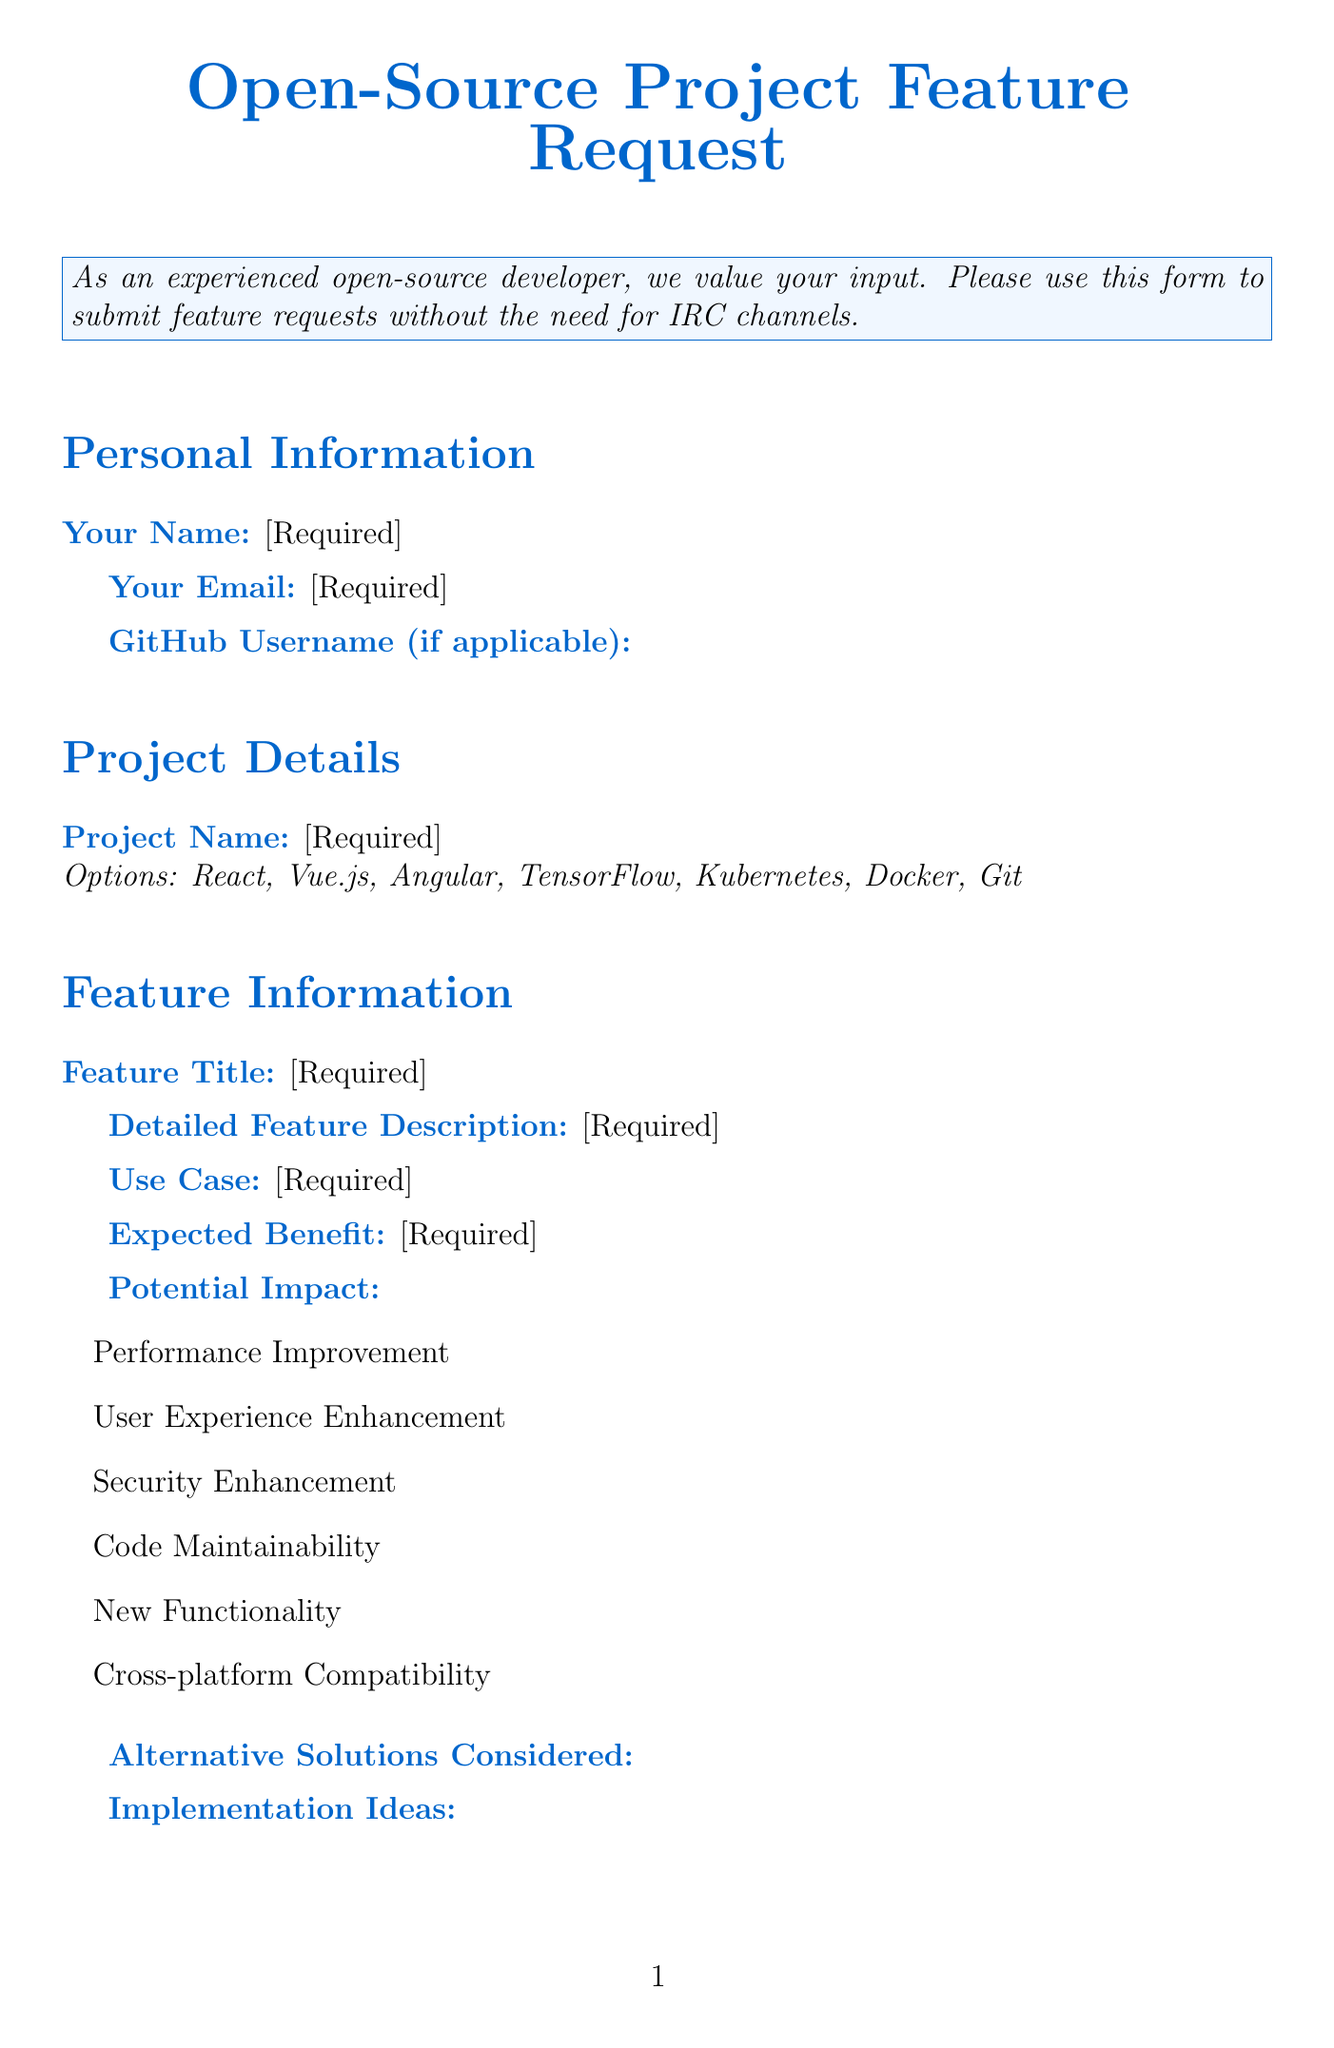what is the title of the form? The title of the form is presented at the top of the document.
Answer: Open-Source Project Feature Request what types of projects can you select? The options for project names are provided in a dropdown list in the document.
Answer: React, Vue.js, Angular, TensorFlow, Kubernetes, Docker, Git which field is required for the requester? The document specifies which fields are marked as required.
Answer: Your Name, Your Email, Project Name, Feature Title, Detailed Feature Description, Use Case, Expected Benefit, Priority, Estimated Complexity, Are you willing to contribute to the implementation?, Preferred Communication Method how many options are available for potential impact? The potential impact section lists various options.
Answer: Six what is the submit button text? The text on the submit button is clearly stated towards the end of the document.
Answer: Submit Feature Request what is the privacy notice regarding personal information? The privacy notice details how personal information will be handled.
Answer: Used solely for the purpose of evaluating and potentially implementing this feature request what communication methods are available in the form? The document lists various options for preferred communication methods.
Answer: GitHub Issues, Mailing List, Slack, Discord, Gitter how many priority options are provided? The priority section offers several choices, which are explicitly stated.
Answer: Four is providing the GitHub username mandatory? The document specifies whether fields are required or optional.
Answer: No 